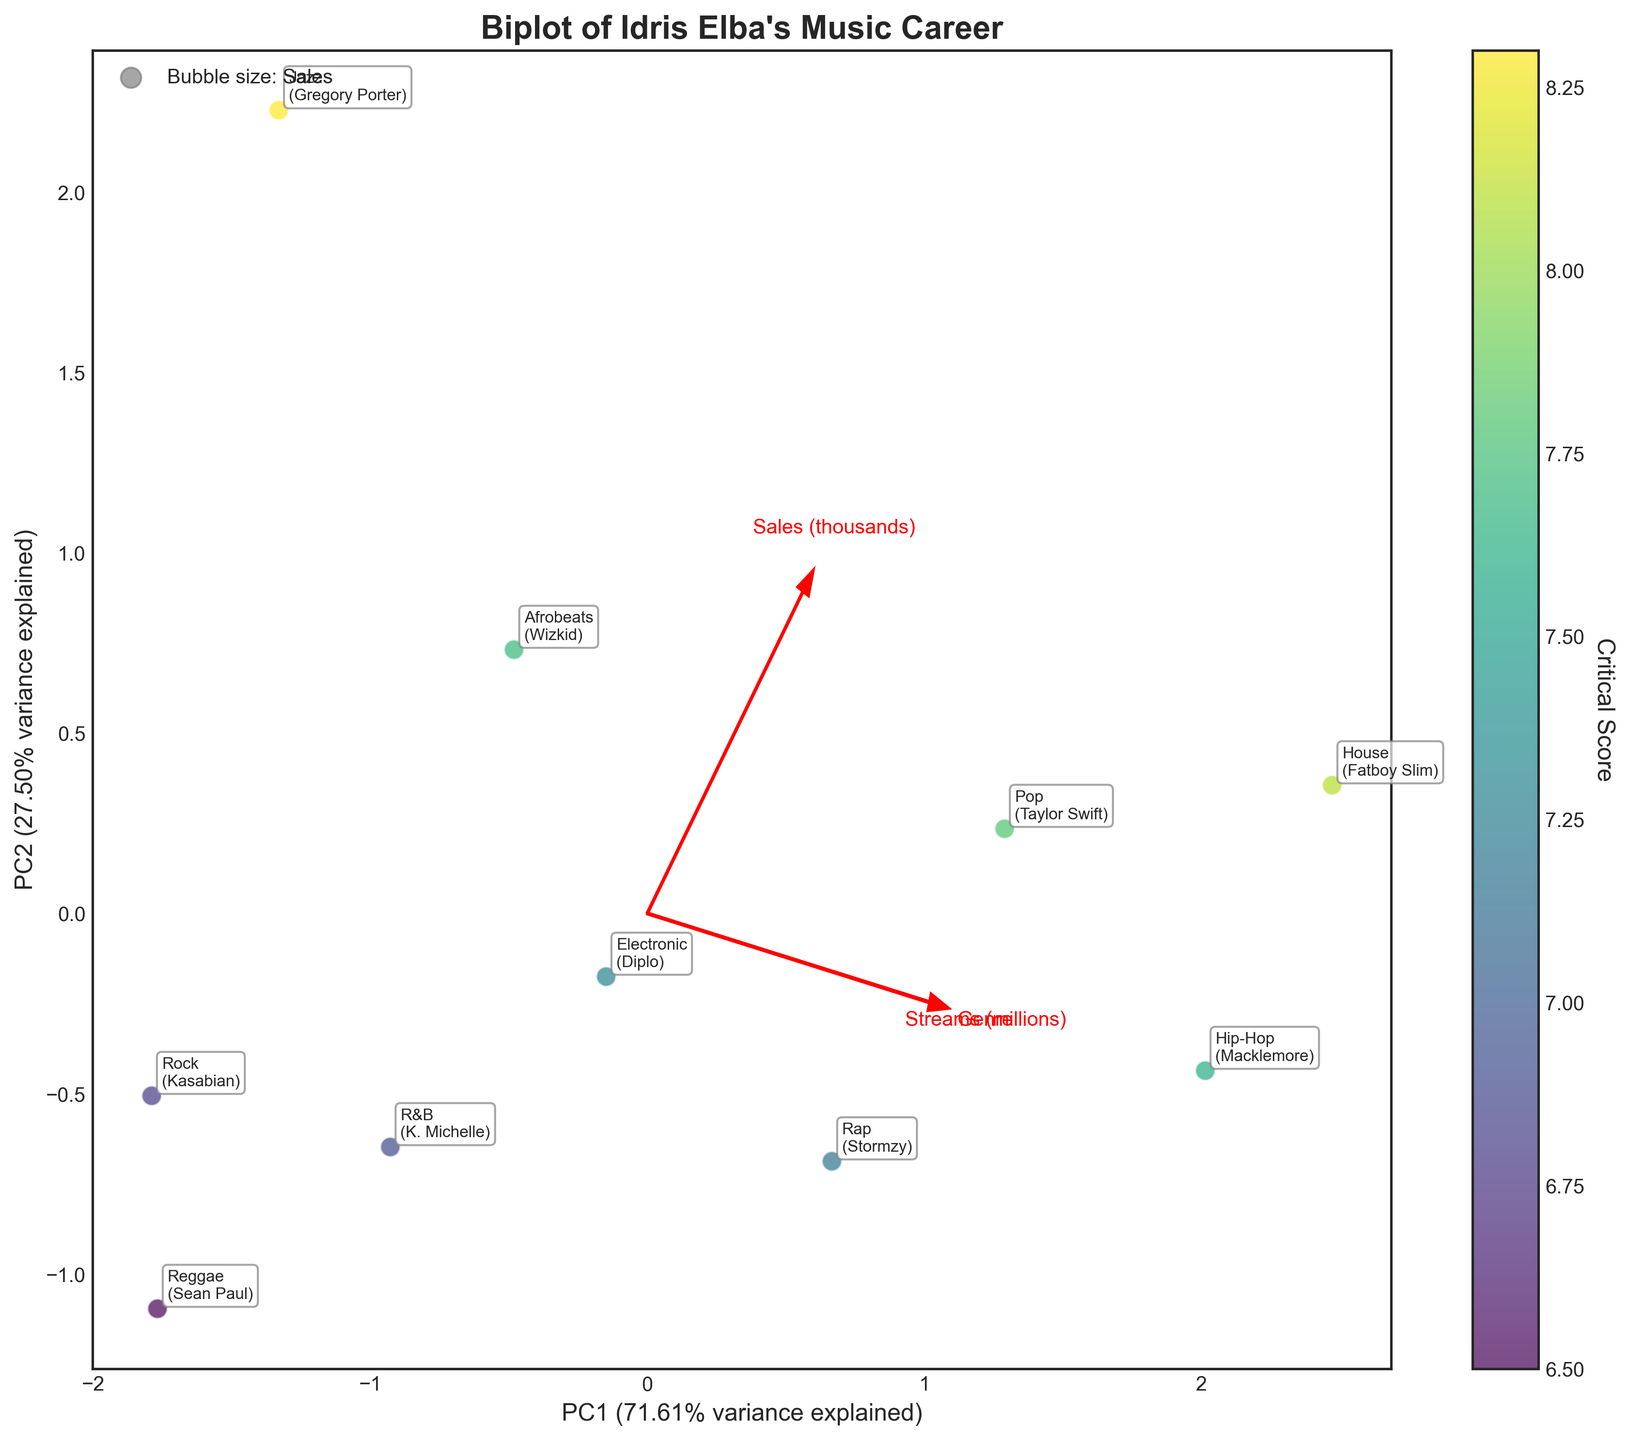What is the title of the biplot? To find the title, look at the top of the biplot where the title is displayed in a larger, bold font.
Answer: Biplot of Idris Elba's Music Career Which genre has collaborated with Taylor Swift? Check the annotations for each data point, which includes the genre and the collaborator's name. Taylor Swift is annotated with the genre "Pop".
Answer: Pop Which genre has the highest critical score? Look at the scatter plot points and their corresponding color intensity, and refer to the color bar that denotes critical scores. The jazz genre, collaborating with Gregory Porter, stands out with the highest score.
Answer: Jazz What percentage of variance is explained by PC1? Look at the axis label for PC1 (x-axis), which includes the percentage of variance explained by the first principal component in parentheses.
Answer: 62.29% Which genre had the lowest sales? Look at the annotations and find the sales information for each genre, indicated by the bubble size and labels on the plot. Jazz, with Gregory Porter, has the lowest sales.
Answer: Jazz Compare the streams between the genres collaborating with Stormzy and Sean Paul. Find the data points for genres collaborating with Stormzy (Rap) and Sean Paul (Reggae) and compare their "Streams (millions)" values. Rap with Stormzy has 12.5 million streams, while Reggae with Sean Paul has 6.2 million streams.
Answer: Rap has more streams than Reggae Which components (streams, sales, critical score) influence PC1 and PC2 the most? Analyze the direction and length of the eigenvectors (arrows) and their proximity to the axes to determine their influence on PC1 and PC2. Sales and streams mainly influence PC1, while critical scores mainly affect PC2.
Answer: Sales and streams for PC1, critical score for PC2 How do genres in collaboration with Fatboy Slim and Wizkid compare in terms of streams and critical score? Locate the House genre with Fatboy Slim and Afrobeats with Wizkid on the plot. Compare their positions concerning the streams and critical score arrows. House has higher streams, while Afrobeats has a slightly better critical score.
Answer: House has higher streams, Afrobeats has a slightly better critical score Among the genres clustered together, what common characteristic do they share? Observe the plot to identify closely positioned genres and check their annotations for common features. Electronic, R&B, and Afrobeats are relatively close and share intermediate stream counts and moderate critical scores.
Answer: Intermediate stream counts and moderate critical scores How is the relationship between streams and sales depicted in the biplot? Examine the direction of the arrows for streams and sales in the biplot. They align closely, indicating a positive correlation between streams and sales.
Answer: Positive correlation 